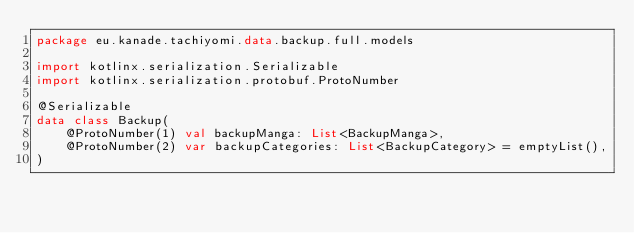Convert code to text. <code><loc_0><loc_0><loc_500><loc_500><_Kotlin_>package eu.kanade.tachiyomi.data.backup.full.models

import kotlinx.serialization.Serializable
import kotlinx.serialization.protobuf.ProtoNumber

@Serializable
data class Backup(
    @ProtoNumber(1) val backupManga: List<BackupManga>,
    @ProtoNumber(2) var backupCategories: List<BackupCategory> = emptyList(),
)
</code> 